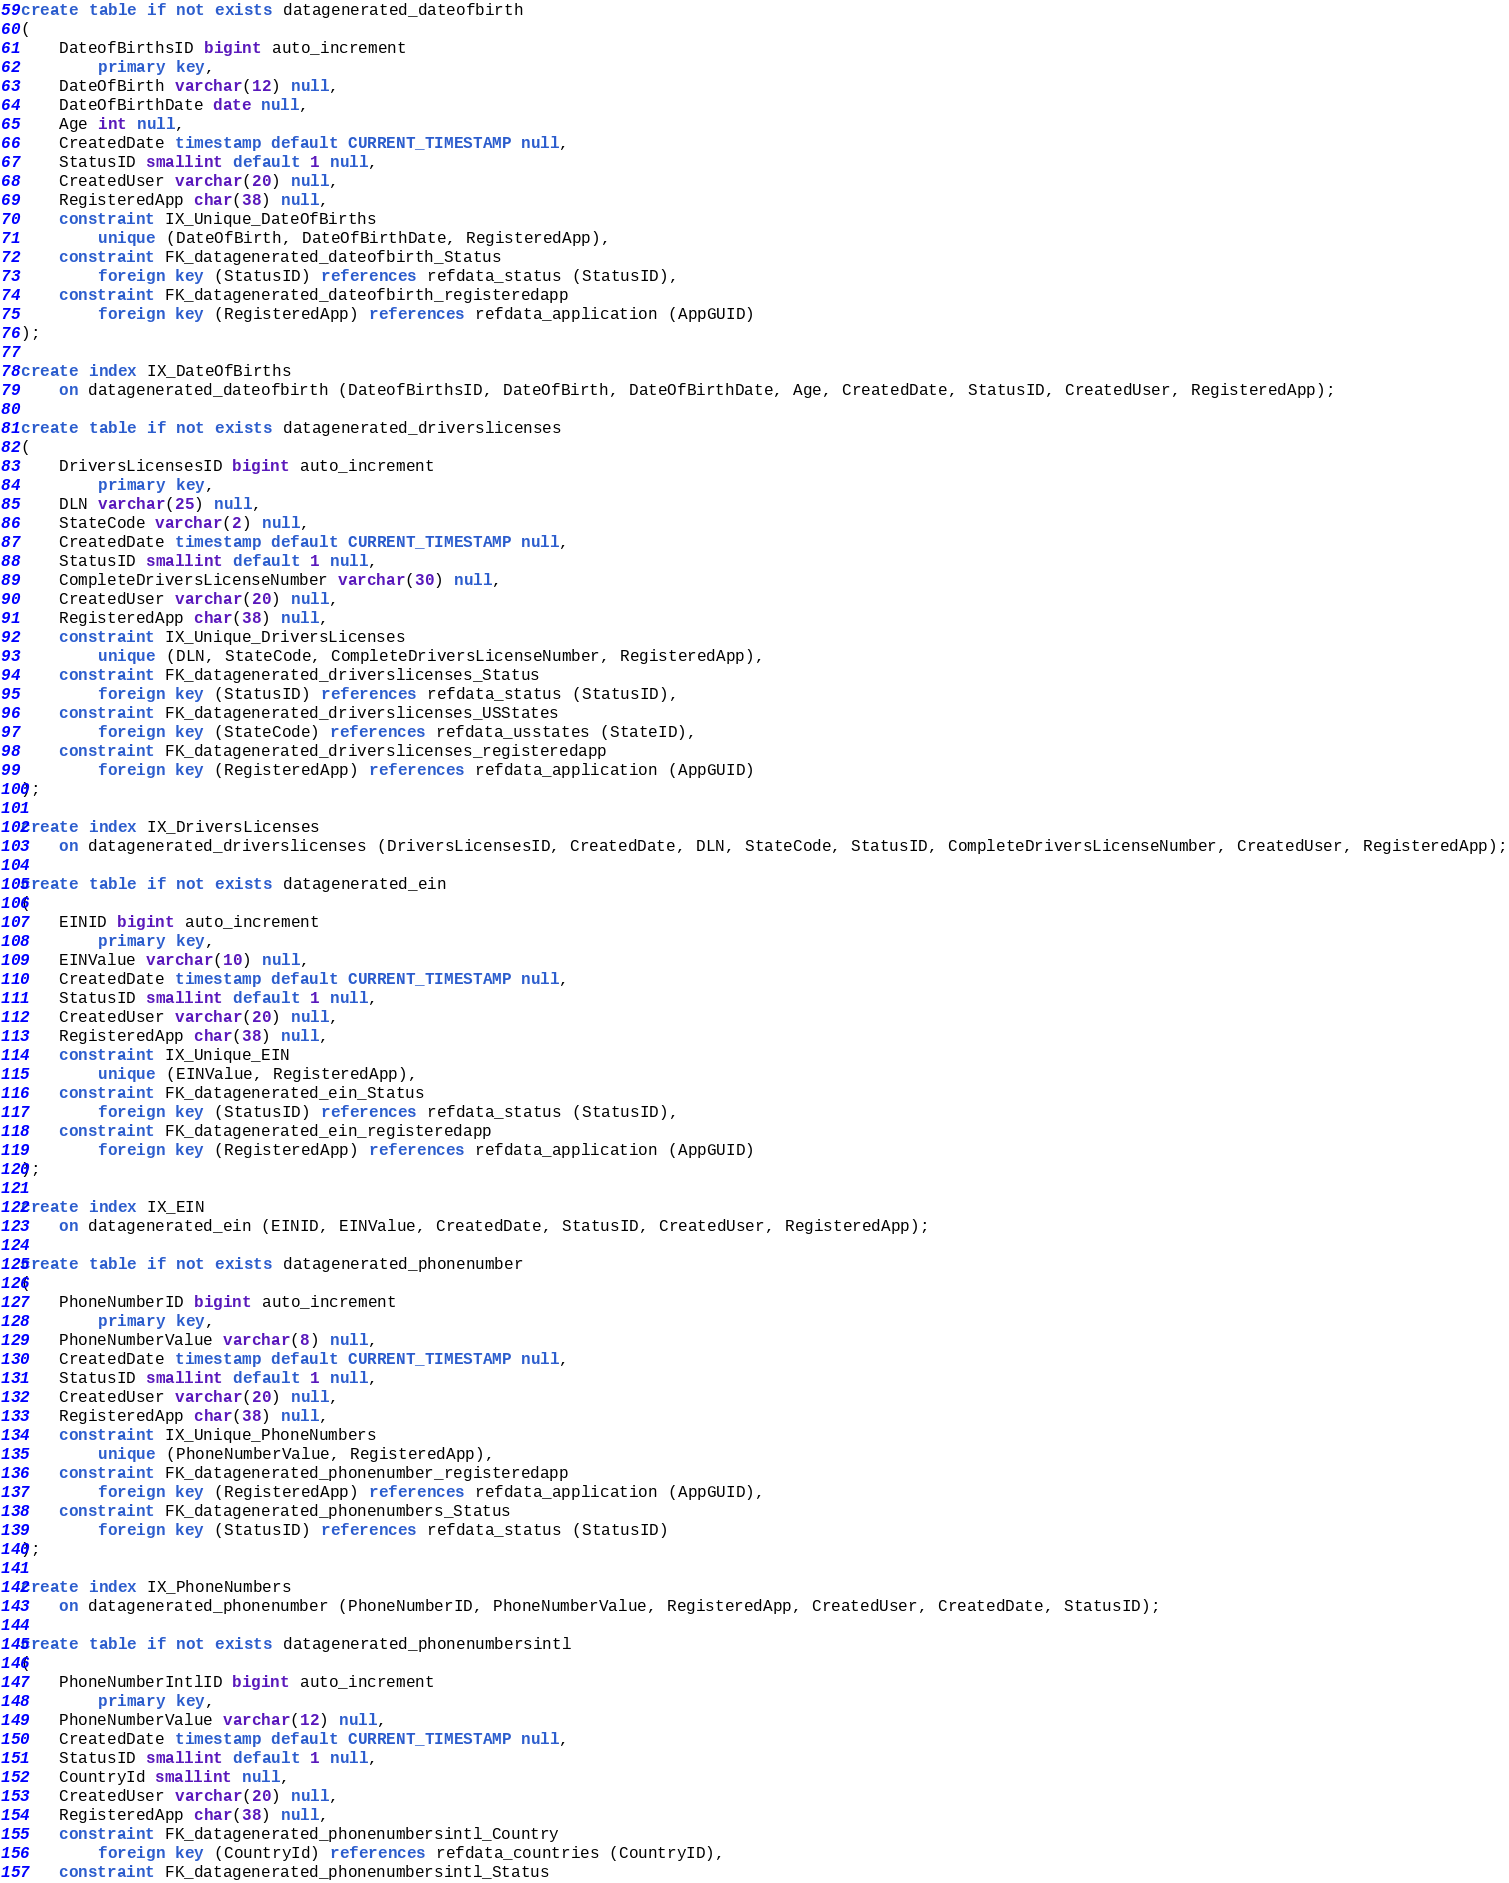Convert code to text. <code><loc_0><loc_0><loc_500><loc_500><_SQL_>
create table if not exists datagenerated_dateofbirth
(
	DateofBirthsID bigint auto_increment
		primary key,
	DateOfBirth varchar(12) null,
	DateOfBirthDate date null,
	Age int null,
	CreatedDate timestamp default CURRENT_TIMESTAMP null,
	StatusID smallint default 1 null,
	CreatedUser varchar(20) null,
	RegisteredApp char(38) null,
	constraint IX_Unique_DateOfBirths
		unique (DateOfBirth, DateOfBirthDate, RegisteredApp),
	constraint FK_datagenerated_dateofbirth_Status
		foreign key (StatusID) references refdata_status (StatusID),
	constraint FK_datagenerated_dateofbirth_registeredapp
		foreign key (RegisteredApp) references refdata_application (AppGUID)
);

create index IX_DateOfBirths
	on datagenerated_dateofbirth (DateofBirthsID, DateOfBirth, DateOfBirthDate, Age, CreatedDate, StatusID, CreatedUser, RegisteredApp);

create table if not exists datagenerated_driverslicenses
(
	DriversLicensesID bigint auto_increment
		primary key,
	DLN varchar(25) null,
	StateCode varchar(2) null,
	CreatedDate timestamp default CURRENT_TIMESTAMP null,
	StatusID smallint default 1 null,
	CompleteDriversLicenseNumber varchar(30) null,
	CreatedUser varchar(20) null,
	RegisteredApp char(38) null,
	constraint IX_Unique_DriversLicenses
		unique (DLN, StateCode, CompleteDriversLicenseNumber, RegisteredApp),
	constraint FK_datagenerated_driverslicenses_Status
		foreign key (StatusID) references refdata_status (StatusID),
	constraint FK_datagenerated_driverslicenses_USStates
		foreign key (StateCode) references refdata_usstates (StateID),
	constraint FK_datagenerated_driverslicenses_registeredapp
		foreign key (RegisteredApp) references refdata_application (AppGUID)
);

create index IX_DriversLicenses
	on datagenerated_driverslicenses (DriversLicensesID, CreatedDate, DLN, StateCode, StatusID, CompleteDriversLicenseNumber, CreatedUser, RegisteredApp);

create table if not exists datagenerated_ein
(
	EINID bigint auto_increment
		primary key,
	EINValue varchar(10) null,
	CreatedDate timestamp default CURRENT_TIMESTAMP null,
	StatusID smallint default 1 null,
	CreatedUser varchar(20) null,
	RegisteredApp char(38) null,
	constraint IX_Unique_EIN
		unique (EINValue, RegisteredApp),
	constraint FK_datagenerated_ein_Status
		foreign key (StatusID) references refdata_status (StatusID),
	constraint FK_datagenerated_ein_registeredapp
		foreign key (RegisteredApp) references refdata_application (AppGUID)
);

create index IX_EIN
	on datagenerated_ein (EINID, EINValue, CreatedDate, StatusID, CreatedUser, RegisteredApp);

create table if not exists datagenerated_phonenumber
(
	PhoneNumberID bigint auto_increment
		primary key,
	PhoneNumberValue varchar(8) null,
	CreatedDate timestamp default CURRENT_TIMESTAMP null,
	StatusID smallint default 1 null,
	CreatedUser varchar(20) null,
	RegisteredApp char(38) null,
	constraint IX_Unique_PhoneNumbers
		unique (PhoneNumberValue, RegisteredApp),
	constraint FK_datagenerated_phonenumber_registeredapp
		foreign key (RegisteredApp) references refdata_application (AppGUID),
	constraint FK_datagenerated_phonenumbers_Status
		foreign key (StatusID) references refdata_status (StatusID)
);

create index IX_PhoneNumbers
	on datagenerated_phonenumber (PhoneNumberID, PhoneNumberValue, RegisteredApp, CreatedUser, CreatedDate, StatusID);

create table if not exists datagenerated_phonenumbersintl
(
	PhoneNumberIntlID bigint auto_increment
		primary key,
	PhoneNumberValue varchar(12) null,
	CreatedDate timestamp default CURRENT_TIMESTAMP null,
	StatusID smallint default 1 null,
	CountryId smallint null,
	CreatedUser varchar(20) null,
	RegisteredApp char(38) null,
	constraint FK_datagenerated_phonenumbersintl_Country
		foreign key (CountryId) references refdata_countries (CountryID),
	constraint FK_datagenerated_phonenumbersintl_Status</code> 